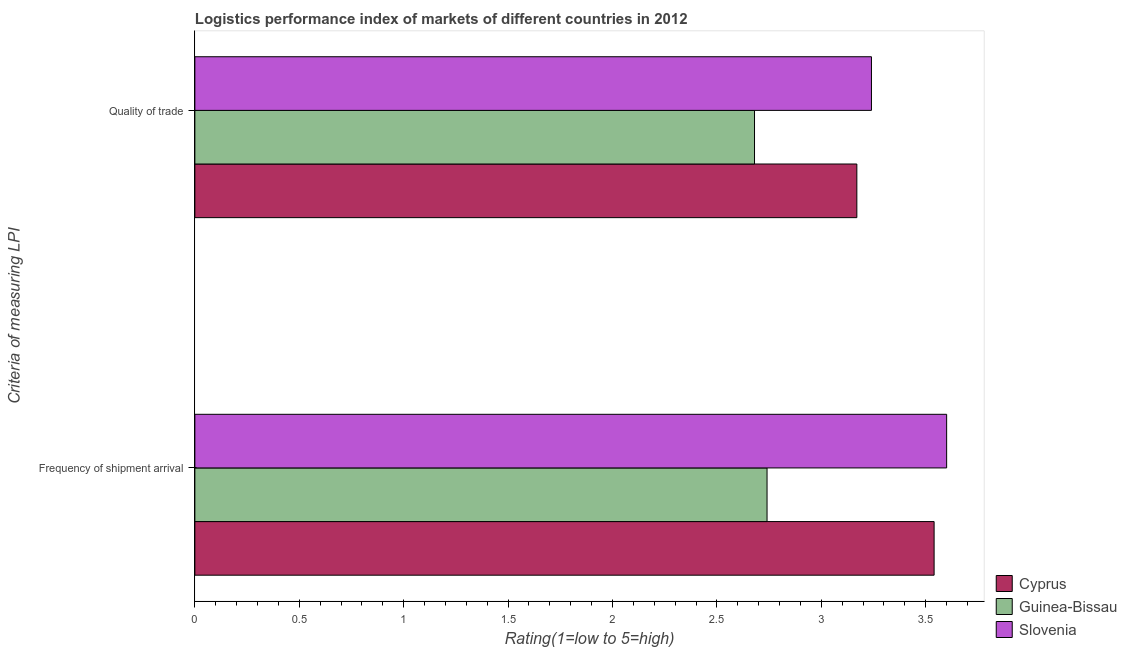How many different coloured bars are there?
Your answer should be compact. 3. How many groups of bars are there?
Your response must be concise. 2. Are the number of bars per tick equal to the number of legend labels?
Offer a very short reply. Yes. Are the number of bars on each tick of the Y-axis equal?
Offer a very short reply. Yes. How many bars are there on the 1st tick from the bottom?
Provide a short and direct response. 3. What is the label of the 1st group of bars from the top?
Offer a very short reply. Quality of trade. What is the lpi of frequency of shipment arrival in Cyprus?
Your response must be concise. 3.54. Across all countries, what is the maximum lpi quality of trade?
Offer a terse response. 3.24. Across all countries, what is the minimum lpi of frequency of shipment arrival?
Offer a very short reply. 2.74. In which country was the lpi quality of trade maximum?
Offer a very short reply. Slovenia. In which country was the lpi quality of trade minimum?
Your answer should be very brief. Guinea-Bissau. What is the total lpi quality of trade in the graph?
Offer a terse response. 9.09. What is the difference between the lpi quality of trade in Slovenia and that in Guinea-Bissau?
Your response must be concise. 0.56. What is the difference between the lpi of frequency of shipment arrival in Guinea-Bissau and the lpi quality of trade in Cyprus?
Provide a short and direct response. -0.43. What is the average lpi of frequency of shipment arrival per country?
Provide a succinct answer. 3.29. What is the difference between the lpi quality of trade and lpi of frequency of shipment arrival in Guinea-Bissau?
Give a very brief answer. -0.06. In how many countries, is the lpi quality of trade greater than 1.9 ?
Make the answer very short. 3. What is the ratio of the lpi of frequency of shipment arrival in Guinea-Bissau to that in Cyprus?
Ensure brevity in your answer.  0.77. In how many countries, is the lpi of frequency of shipment arrival greater than the average lpi of frequency of shipment arrival taken over all countries?
Give a very brief answer. 2. What does the 2nd bar from the top in Quality of trade represents?
Provide a succinct answer. Guinea-Bissau. What does the 3rd bar from the bottom in Quality of trade represents?
Offer a terse response. Slovenia. How many bars are there?
Your answer should be compact. 6. Are all the bars in the graph horizontal?
Offer a terse response. Yes. How many countries are there in the graph?
Keep it short and to the point. 3. What is the difference between two consecutive major ticks on the X-axis?
Ensure brevity in your answer.  0.5. Are the values on the major ticks of X-axis written in scientific E-notation?
Your answer should be very brief. No. Does the graph contain any zero values?
Give a very brief answer. No. Where does the legend appear in the graph?
Make the answer very short. Bottom right. How many legend labels are there?
Ensure brevity in your answer.  3. How are the legend labels stacked?
Give a very brief answer. Vertical. What is the title of the graph?
Provide a succinct answer. Logistics performance index of markets of different countries in 2012. What is the label or title of the X-axis?
Offer a terse response. Rating(1=low to 5=high). What is the label or title of the Y-axis?
Your response must be concise. Criteria of measuring LPI. What is the Rating(1=low to 5=high) in Cyprus in Frequency of shipment arrival?
Provide a succinct answer. 3.54. What is the Rating(1=low to 5=high) of Guinea-Bissau in Frequency of shipment arrival?
Offer a very short reply. 2.74. What is the Rating(1=low to 5=high) in Slovenia in Frequency of shipment arrival?
Offer a terse response. 3.6. What is the Rating(1=low to 5=high) in Cyprus in Quality of trade?
Provide a succinct answer. 3.17. What is the Rating(1=low to 5=high) in Guinea-Bissau in Quality of trade?
Offer a terse response. 2.68. What is the Rating(1=low to 5=high) in Slovenia in Quality of trade?
Your answer should be compact. 3.24. Across all Criteria of measuring LPI, what is the maximum Rating(1=low to 5=high) in Cyprus?
Your response must be concise. 3.54. Across all Criteria of measuring LPI, what is the maximum Rating(1=low to 5=high) of Guinea-Bissau?
Your answer should be compact. 2.74. Across all Criteria of measuring LPI, what is the maximum Rating(1=low to 5=high) of Slovenia?
Your answer should be very brief. 3.6. Across all Criteria of measuring LPI, what is the minimum Rating(1=low to 5=high) of Cyprus?
Keep it short and to the point. 3.17. Across all Criteria of measuring LPI, what is the minimum Rating(1=low to 5=high) of Guinea-Bissau?
Keep it short and to the point. 2.68. Across all Criteria of measuring LPI, what is the minimum Rating(1=low to 5=high) of Slovenia?
Make the answer very short. 3.24. What is the total Rating(1=low to 5=high) of Cyprus in the graph?
Your response must be concise. 6.71. What is the total Rating(1=low to 5=high) of Guinea-Bissau in the graph?
Your answer should be compact. 5.42. What is the total Rating(1=low to 5=high) of Slovenia in the graph?
Offer a terse response. 6.84. What is the difference between the Rating(1=low to 5=high) in Cyprus in Frequency of shipment arrival and that in Quality of trade?
Provide a short and direct response. 0.37. What is the difference between the Rating(1=low to 5=high) in Slovenia in Frequency of shipment arrival and that in Quality of trade?
Make the answer very short. 0.36. What is the difference between the Rating(1=low to 5=high) of Cyprus in Frequency of shipment arrival and the Rating(1=low to 5=high) of Guinea-Bissau in Quality of trade?
Ensure brevity in your answer.  0.86. What is the average Rating(1=low to 5=high) of Cyprus per Criteria of measuring LPI?
Provide a short and direct response. 3.35. What is the average Rating(1=low to 5=high) in Guinea-Bissau per Criteria of measuring LPI?
Your answer should be very brief. 2.71. What is the average Rating(1=low to 5=high) of Slovenia per Criteria of measuring LPI?
Provide a succinct answer. 3.42. What is the difference between the Rating(1=low to 5=high) of Cyprus and Rating(1=low to 5=high) of Slovenia in Frequency of shipment arrival?
Your answer should be compact. -0.06. What is the difference between the Rating(1=low to 5=high) of Guinea-Bissau and Rating(1=low to 5=high) of Slovenia in Frequency of shipment arrival?
Give a very brief answer. -0.86. What is the difference between the Rating(1=low to 5=high) of Cyprus and Rating(1=low to 5=high) of Guinea-Bissau in Quality of trade?
Offer a terse response. 0.49. What is the difference between the Rating(1=low to 5=high) of Cyprus and Rating(1=low to 5=high) of Slovenia in Quality of trade?
Ensure brevity in your answer.  -0.07. What is the difference between the Rating(1=low to 5=high) in Guinea-Bissau and Rating(1=low to 5=high) in Slovenia in Quality of trade?
Your answer should be very brief. -0.56. What is the ratio of the Rating(1=low to 5=high) of Cyprus in Frequency of shipment arrival to that in Quality of trade?
Your answer should be very brief. 1.12. What is the ratio of the Rating(1=low to 5=high) of Guinea-Bissau in Frequency of shipment arrival to that in Quality of trade?
Provide a short and direct response. 1.02. What is the difference between the highest and the second highest Rating(1=low to 5=high) in Cyprus?
Give a very brief answer. 0.37. What is the difference between the highest and the second highest Rating(1=low to 5=high) in Slovenia?
Provide a short and direct response. 0.36. What is the difference between the highest and the lowest Rating(1=low to 5=high) in Cyprus?
Offer a terse response. 0.37. What is the difference between the highest and the lowest Rating(1=low to 5=high) in Slovenia?
Your answer should be compact. 0.36. 